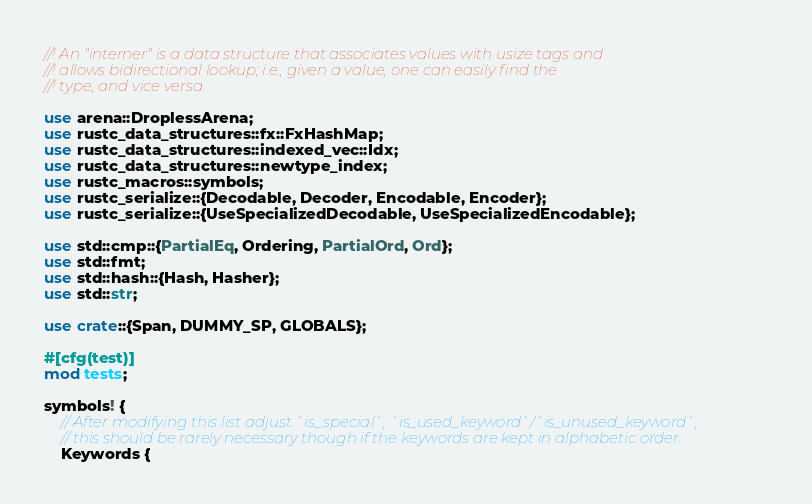<code> <loc_0><loc_0><loc_500><loc_500><_Rust_>//! An "interner" is a data structure that associates values with usize tags and
//! allows bidirectional lookup; i.e., given a value, one can easily find the
//! type, and vice versa.

use arena::DroplessArena;
use rustc_data_structures::fx::FxHashMap;
use rustc_data_structures::indexed_vec::Idx;
use rustc_data_structures::newtype_index;
use rustc_macros::symbols;
use rustc_serialize::{Decodable, Decoder, Encodable, Encoder};
use rustc_serialize::{UseSpecializedDecodable, UseSpecializedEncodable};

use std::cmp::{PartialEq, Ordering, PartialOrd, Ord};
use std::fmt;
use std::hash::{Hash, Hasher};
use std::str;

use crate::{Span, DUMMY_SP, GLOBALS};

#[cfg(test)]
mod tests;

symbols! {
    // After modifying this list adjust `is_special`, `is_used_keyword`/`is_unused_keyword`,
    // this should be rarely necessary though if the keywords are kept in alphabetic order.
    Keywords {</code> 